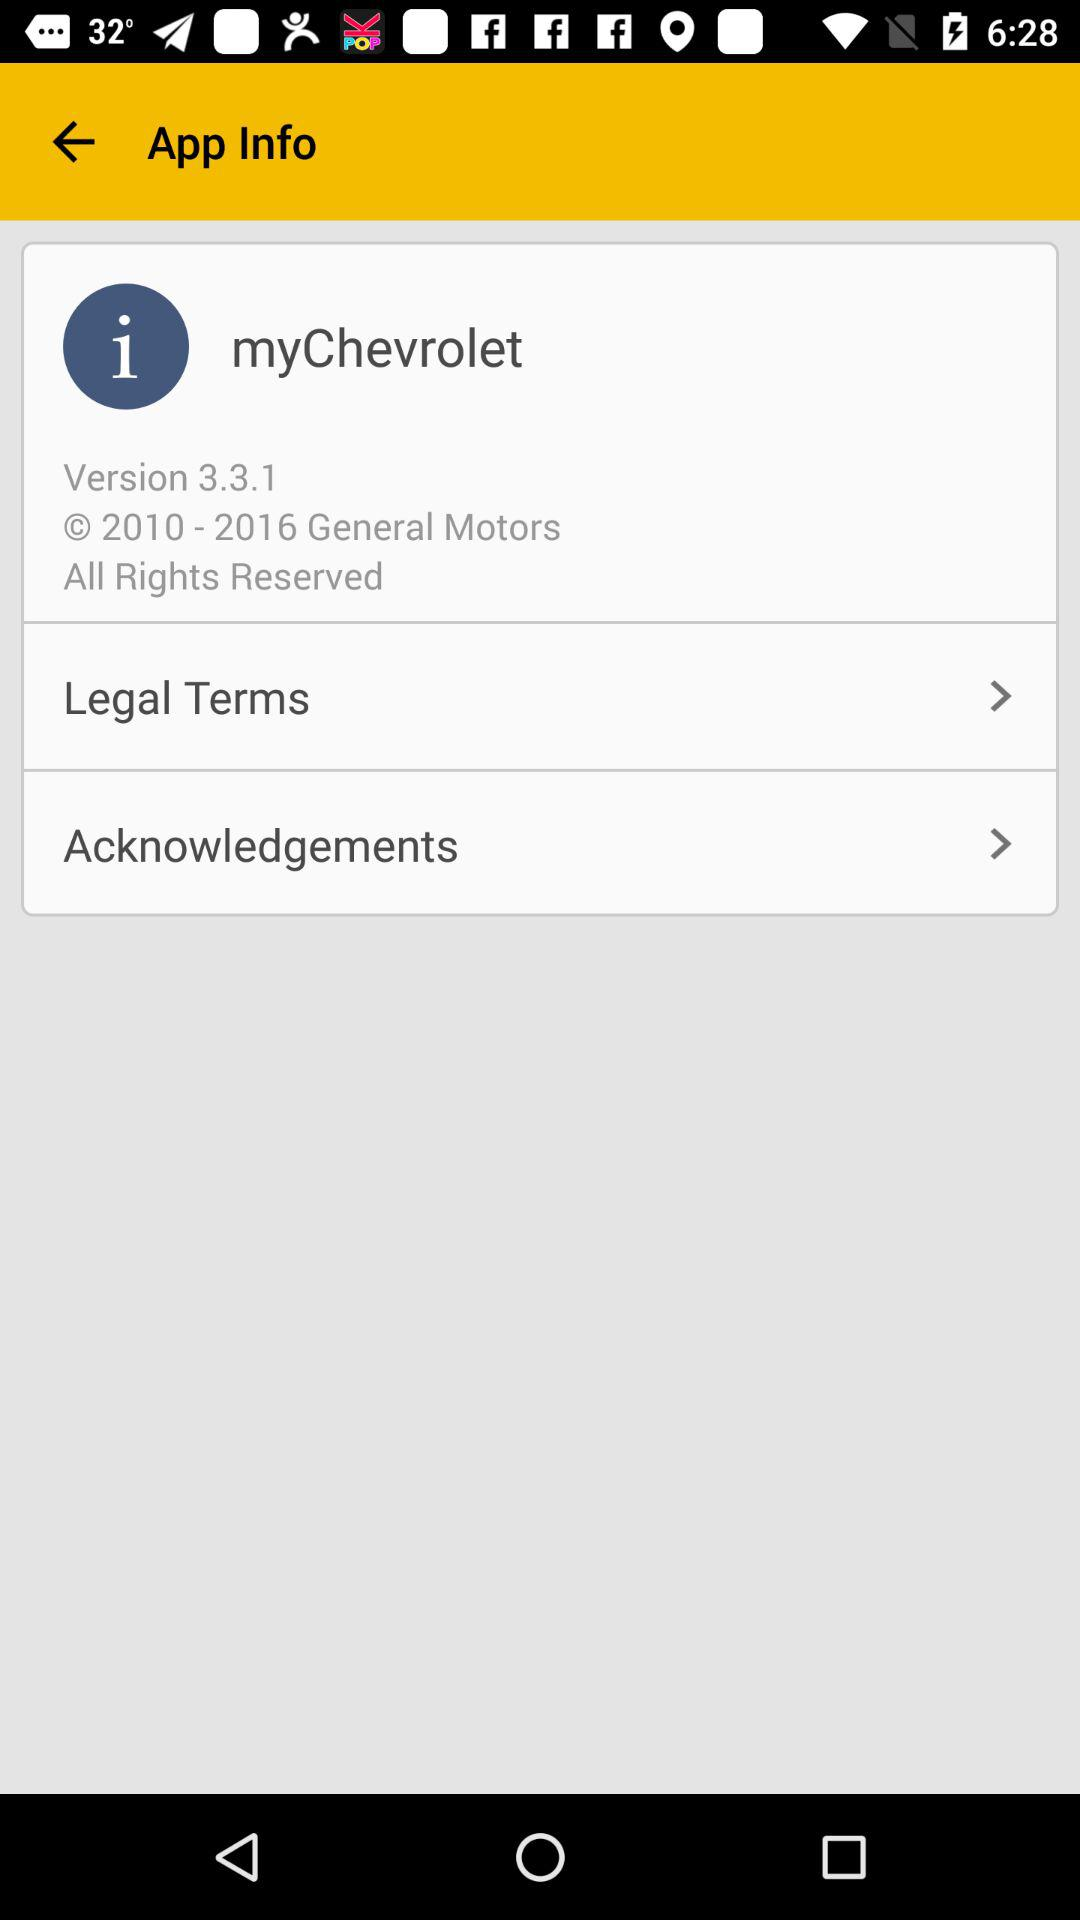Which version of the application is this? The version is 3.3.1. 